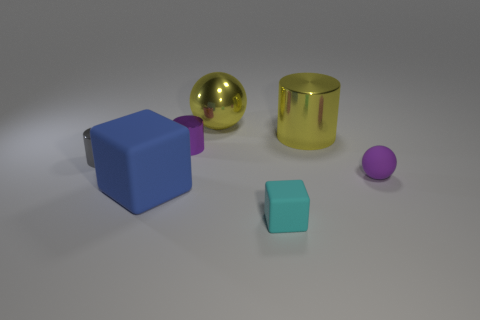The cyan thing that is the same material as the big blue block is what shape?
Offer a very short reply. Cube. Are there any other things of the same color as the large matte object?
Ensure brevity in your answer.  No. What material is the small thing that is on the right side of the yellow metallic object that is to the right of the cyan matte block?
Provide a succinct answer. Rubber. Is there a metal object of the same shape as the cyan rubber thing?
Make the answer very short. No. How many other objects are there of the same shape as the gray metal object?
Offer a terse response. 2. There is a object that is both to the right of the small cyan matte object and behind the tiny gray metal object; what shape is it?
Ensure brevity in your answer.  Cylinder. How big is the rubber cube that is on the left side of the tiny cube?
Keep it short and to the point. Large. Is the size of the purple metallic cylinder the same as the cyan thing?
Provide a succinct answer. Yes. Are there fewer tiny spheres behind the small gray cylinder than gray cylinders in front of the tiny purple ball?
Offer a very short reply. No. There is a cylinder that is both in front of the yellow cylinder and on the right side of the gray metallic cylinder; how big is it?
Keep it short and to the point. Small. 